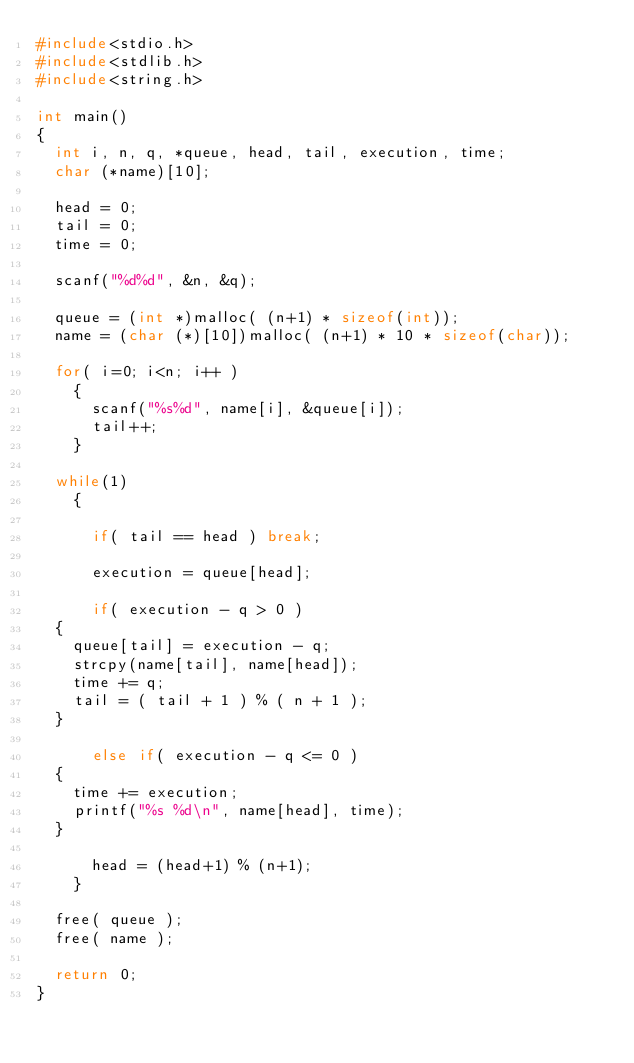Convert code to text. <code><loc_0><loc_0><loc_500><loc_500><_C_>#include<stdio.h>
#include<stdlib.h>
#include<string.h>

int main()
{
  int i, n, q, *queue, head, tail, execution, time;
  char (*name)[10];

  head = 0;
  tail = 0;
  time = 0;

  scanf("%d%d", &n, &q);

  queue = (int *)malloc( (n+1) * sizeof(int));
  name = (char (*)[10])malloc( (n+1) * 10 * sizeof(char));

  for( i=0; i<n; i++ )
    {
      scanf("%s%d", name[i], &queue[i]);
      tail++;
    }

  while(1)
    {

      if( tail == head ) break;

      execution = queue[head];

      if( execution - q > 0 )
	{
	  queue[tail] = execution - q;
	  strcpy(name[tail], name[head]);
	  time += q;
	  tail = ( tail + 1 ) % ( n + 1 );
	}

      else if( execution - q <= 0 )
	{
	  time += execution;
	  printf("%s %d\n", name[head], time);
	}

      head = (head+1) % (n+1);
    }

  free( queue );
  free( name );

  return 0;
}

</code> 